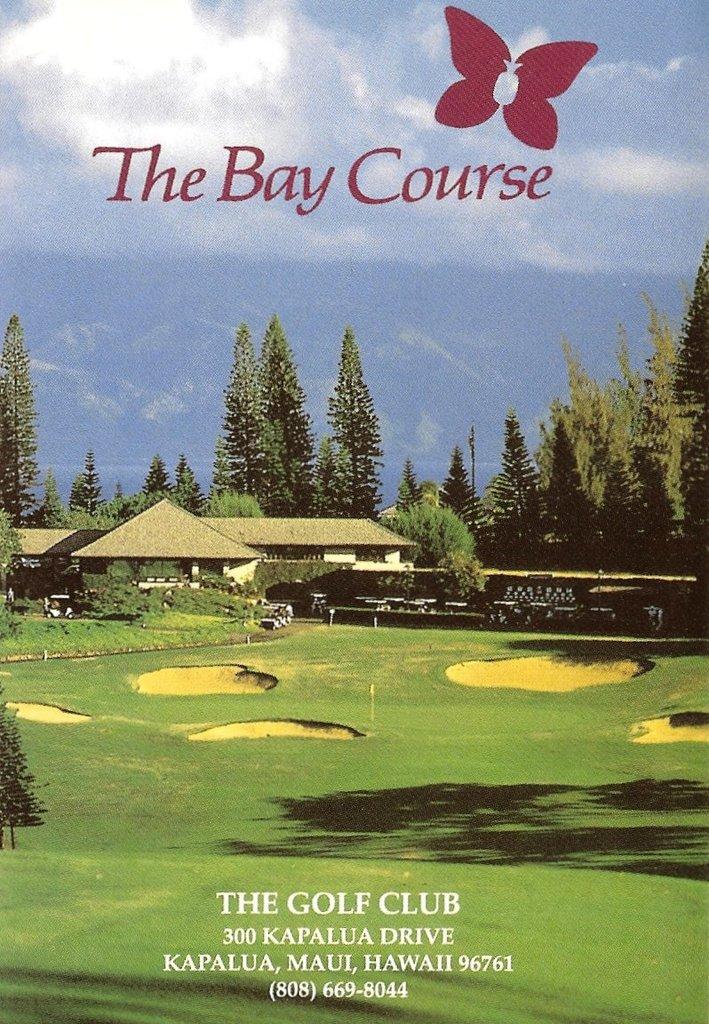What course is this?
Offer a terse response. The bay course. What is the address of the course?
Make the answer very short. 300 kapalua drive. 